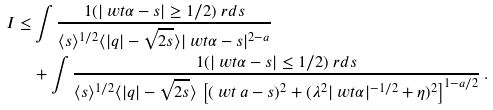<formula> <loc_0><loc_0><loc_500><loc_500>I \leq & \int \frac { { 1 } ( | \ w t \alpha - s | \geq 1 / 2 ) \ r d s } { \langle s \rangle ^ { 1 / 2 } \langle | q | - \sqrt { 2 s } \rangle | \ w t \alpha - s | ^ { 2 - a } } \\ & + \int \frac { { 1 } ( | \ w t \alpha - s | \leq 1 / 2 ) \ r d s } { \langle s \rangle ^ { 1 / 2 } \langle | q | - \sqrt { 2 s } \rangle \, \left [ ( \ w t \ a - s ) ^ { 2 } + ( \lambda ^ { 2 } | \ w t \alpha | ^ { - 1 / 2 } + \eta ) ^ { 2 } \right ] ^ { 1 - a / 2 } } \, .</formula> 